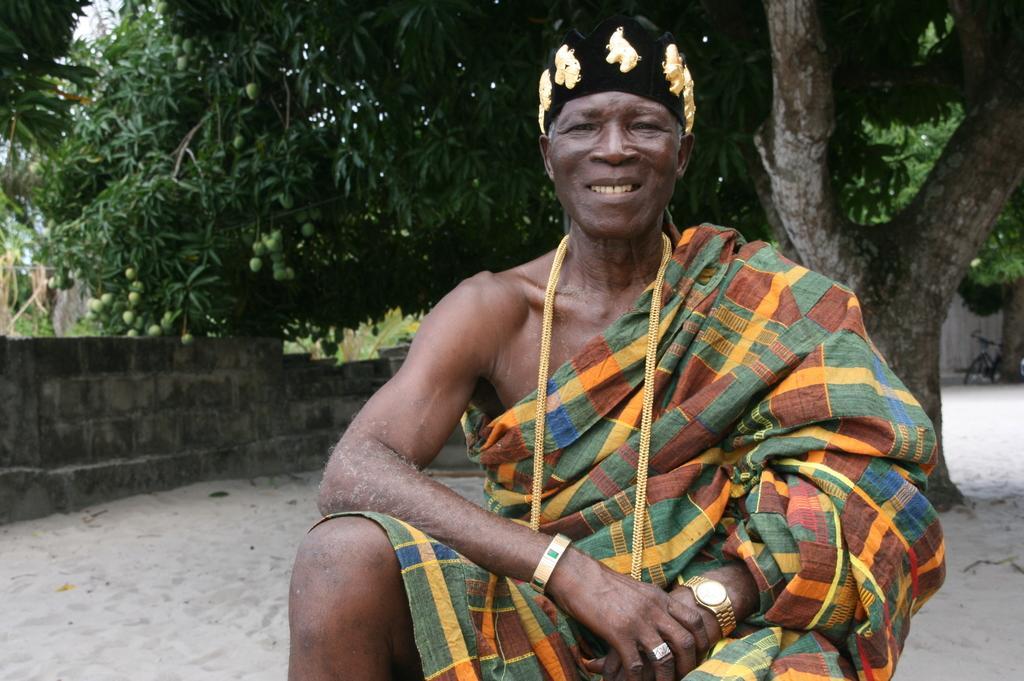Could you give a brief overview of what you see in this image? In this image I can see a man sitting, smiling and giving pose for the picture. On the left side there is a wall. In the background there are some trees. On the left side, I can see the mangoes to a tree. 